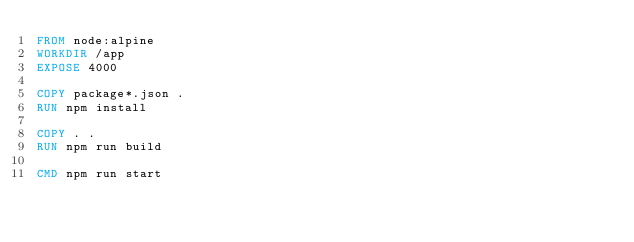<code> <loc_0><loc_0><loc_500><loc_500><_Dockerfile_>FROM node:alpine
WORKDIR /app
EXPOSE 4000

COPY package*.json .
RUN npm install

COPY . .
RUN npm run build

CMD npm run start</code> 